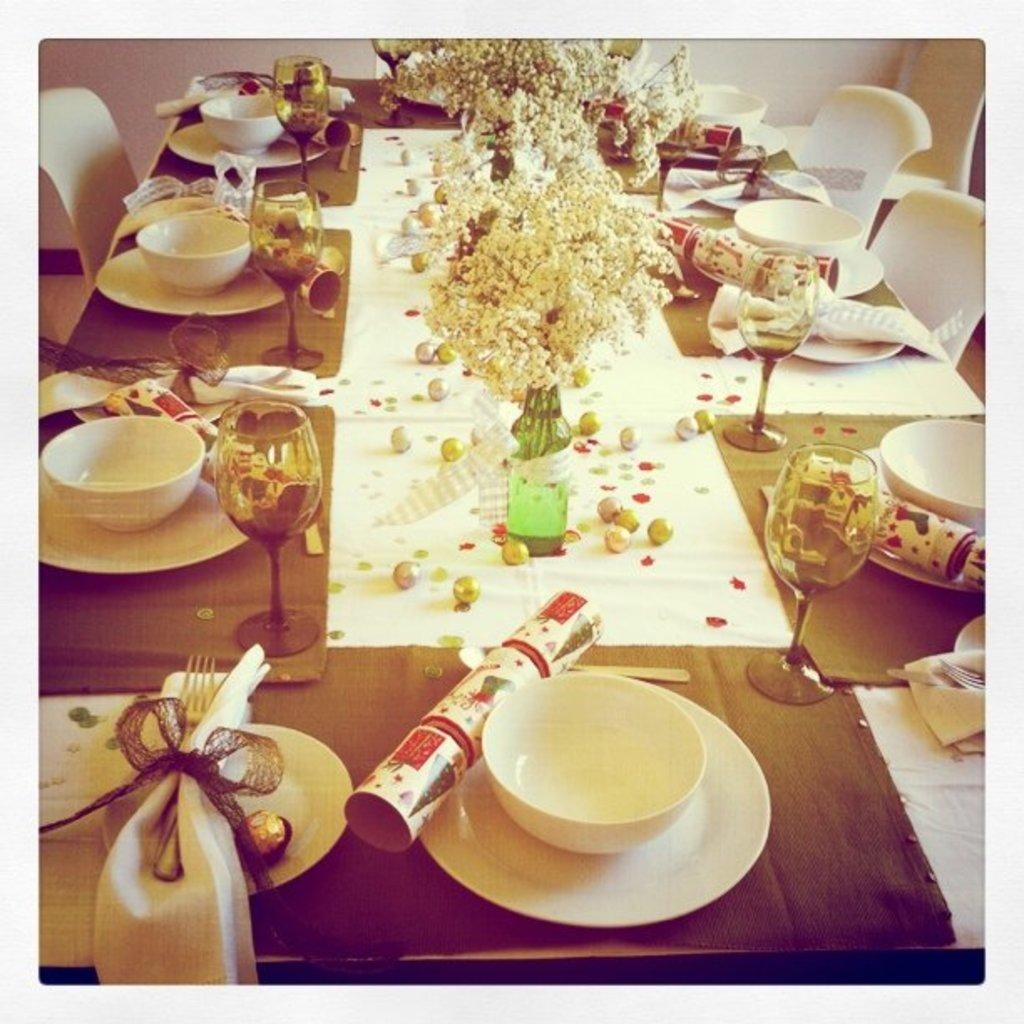What is on the table in the image? There is a flower vase with a ribbon, glasses, bowls, a card, plates, and balls on the table. What color are the chairs beside the table? The chairs beside the table are white. How many types of tableware can be seen in the image? There are three types of tableware visible: glasses, bowls, and plates. What type of tree is growing in the middle of the table? There is no tree growing on the table in the image. What kind of operation is being performed on the table? There is no operation being performed on the table in the image. 